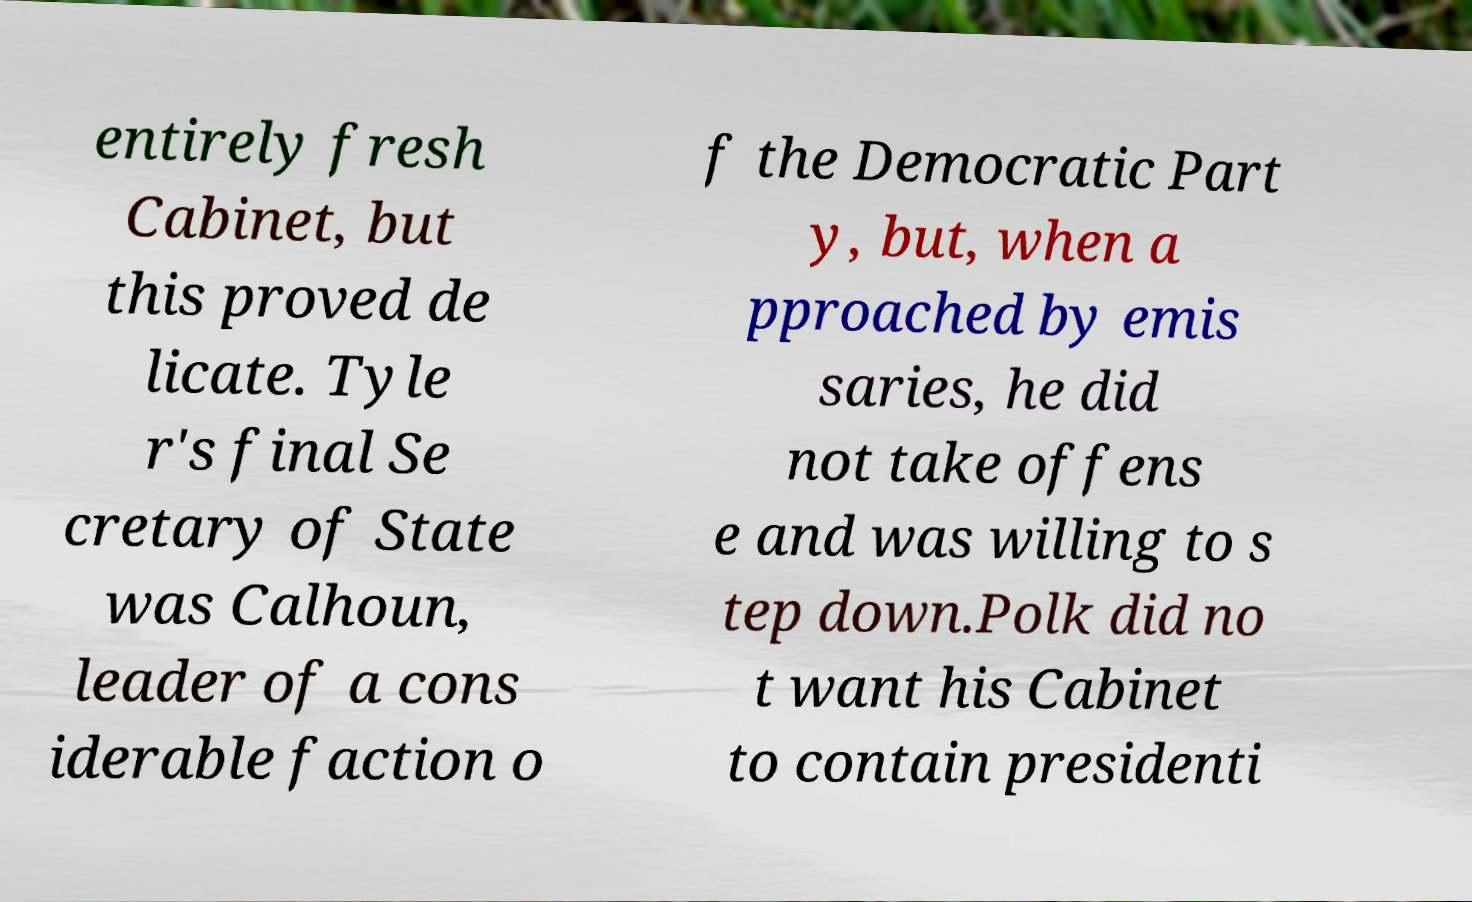I need the written content from this picture converted into text. Can you do that? entirely fresh Cabinet, but this proved de licate. Tyle r's final Se cretary of State was Calhoun, leader of a cons iderable faction o f the Democratic Part y, but, when a pproached by emis saries, he did not take offens e and was willing to s tep down.Polk did no t want his Cabinet to contain presidenti 